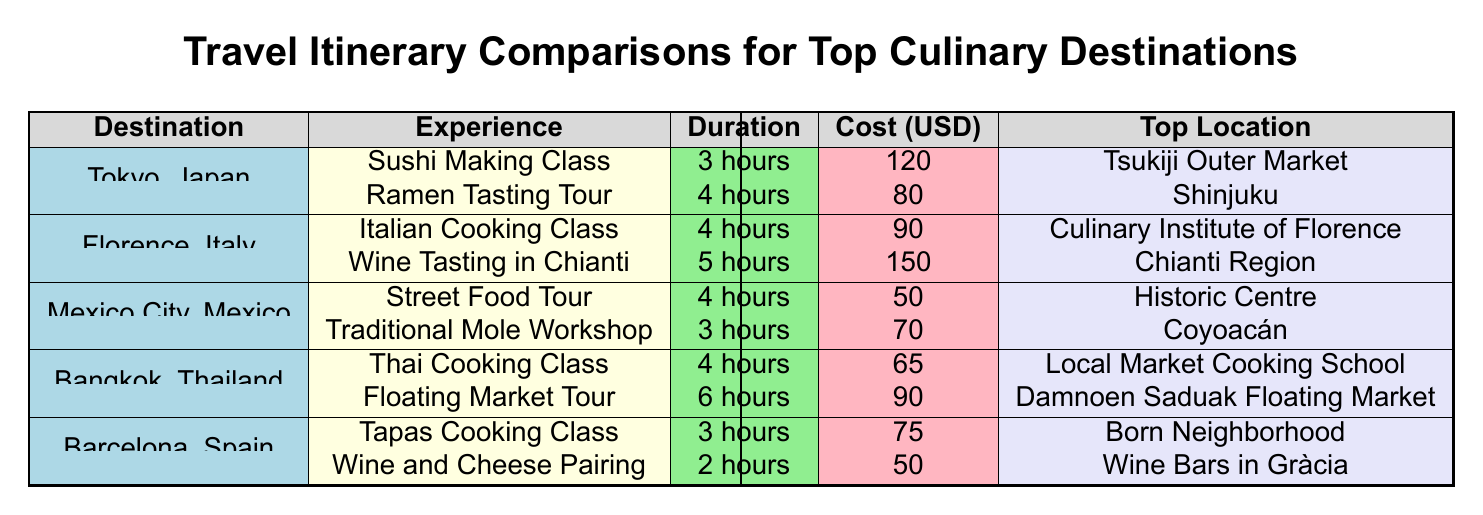What are the popular dishes in the Sushi Making Class? According to the table under Tokyo, Japan's culinary experiences, the Sushi Making Class has two listed popular dishes: Nigiri and Maki.
Answer: Nigiri, Maki How much does the Wine Tasting in Chianti cost? From the Florence, Italy section, the Wine Tasting in Chianti has a cost of 150 USD.
Answer: 150 Which destination offers a traditional cooking class with the lowest cost? By examining the costs in the table, the Street Food Tour in Mexico City is the lowest at 50 USD, compared to all other experiences which are higher.
Answer: Mexico City What is the average duration of culinary experiences in Barcelona, Spain? For Barcelona, the durations of culinary experiences are 3 hours (Tapas Cooking Class) and 2 hours (Wine and Cheese Pairing). First, add the durations: 3 + 2 = 5 hours. To find the average for 2 experiences, divide by 2: 5 / 2 = 2.5 hours.
Answer: 2.5 hours Is the Floating Market Tour longer than the Ramen Tasting Tour? The Floating Market Tour lasts for 6 hours, while the Ramen Tasting Tour lasts for 4 hours. Since 6 is greater than 4, the answer is yes.
Answer: Yes What is the total cost of the culinary experiences in Mexico City? In Mexico City, there are two culinary experiences: the Street Food Tour costs 50 USD, and the Traditional Mole Workshop costs 70 USD. Adding these together gives 50 + 70 = 120 USD for the total cost.
Answer: 120 Which destination has a cooking experience that lasts 6 hours? Looking through the table, the Floating Market Tour in Bangkok lasts for 6 hours, making it the only experience that matches this duration.
Answer: Bangkok What is the cost difference between the most expensive experience in Tokyo and the most expensive in Barcelona? The most expensive culinary experience in Tokyo is the Sushi Making Class at 120 USD, while in Barcelona, the most expensive is the Tapas Cooking Class at 75 USD. Calculating the difference, we find 120 - 75 = 45 USD.
Answer: 45 Does the Italian Cooking Class last longer than the Thai Cooking Class? The duration of the Italian Cooking Class is 4 hours, and the Thai Cooking Class also has a duration of 4 hours. Therefore, they are equal in duration, answering this question with no.
Answer: No 